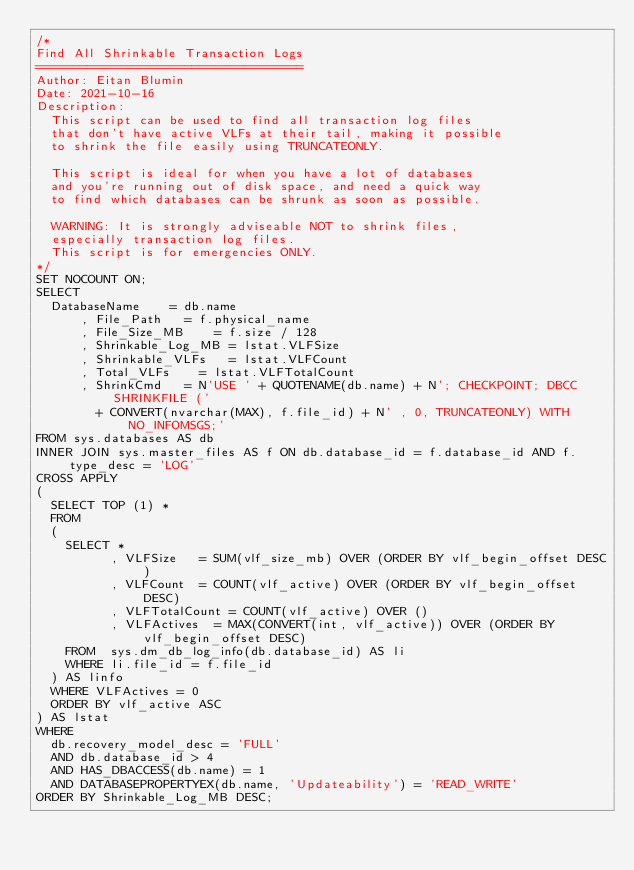Convert code to text. <code><loc_0><loc_0><loc_500><loc_500><_SQL_>/*
Find All Shrinkable Transaction Logs
====================================
Author: Eitan Blumin
Date: 2021-10-16
Description:
	This script can be used to find all transaction log files
	that don't have active VLFs at their tail, making it possible
	to shrink the file easily using TRUNCATEONLY.

	This script is ideal for when you have a lot of databases
	and you're running out of disk space, and need a quick way
	to find which databases can be shrunk as soon as possible.

	WARNING: It is strongly adviseable NOT to shrink files,
	especially transaction log files.
	This script is for emergencies ONLY.
*/
SET NOCOUNT ON;
SELECT
	DatabaseName		= db.name
      , File_Path		= f.physical_name
      , File_Size_MB		= f.size / 128
      , Shrinkable_Log_MB	= lstat.VLFSize
      , Shrinkable_VLFs		= lstat.VLFCount
      , Total_VLFs		= lstat.VLFTotalCount
      , ShrinkCmd		= N'USE ' + QUOTENAME(db.name) + N'; CHECKPOINT; DBCC SHRINKFILE ('
				+ CONVERT(nvarchar(MAX), f.file_id) + N' , 0, TRUNCATEONLY) WITH NO_INFOMSGS;'
FROM sys.databases AS db
INNER JOIN sys.master_files AS f ON db.database_id = f.database_id AND f.type_desc = 'LOG'
CROSS APPLY
(
	SELECT TOP (1) *
	FROM
	(
		SELECT *
		      , VLFSize		= SUM(vlf_size_mb) OVER (ORDER BY vlf_begin_offset DESC)
		      , VLFCount	= COUNT(vlf_active) OVER (ORDER BY vlf_begin_offset DESC)
		      , VLFTotalCount	= COUNT(vlf_active) OVER ()
		      , VLFActives	= MAX(CONVERT(int, vlf_active)) OVER (ORDER BY vlf_begin_offset DESC)
		FROM	sys.dm_db_log_info(db.database_id) AS li
		WHERE	li.file_id = f.file_id
	) AS linfo
	WHERE	VLFActives = 0
	ORDER BY vlf_active ASC
) AS lstat
WHERE
	db.recovery_model_desc = 'FULL'
	AND db.database_id > 4
	AND HAS_DBACCESS(db.name) = 1
	AND DATABASEPROPERTYEX(db.name, 'Updateability') = 'READ_WRITE'
ORDER BY Shrinkable_Log_MB DESC;
</code> 